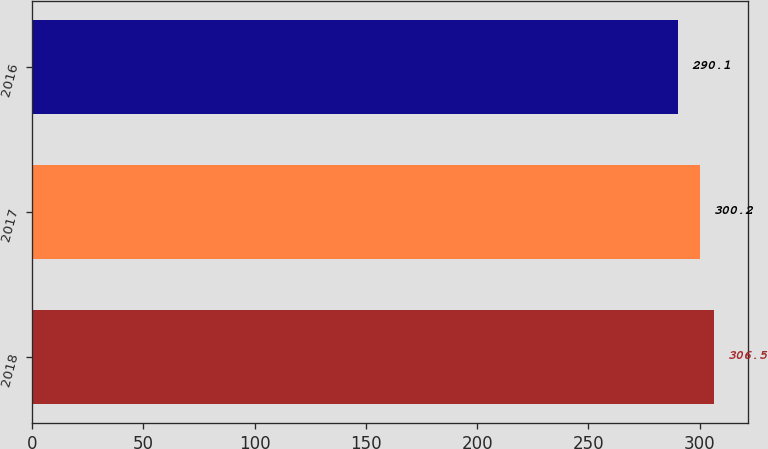Convert chart to OTSL. <chart><loc_0><loc_0><loc_500><loc_500><bar_chart><fcel>2018<fcel>2017<fcel>2016<nl><fcel>306.5<fcel>300.2<fcel>290.1<nl></chart> 